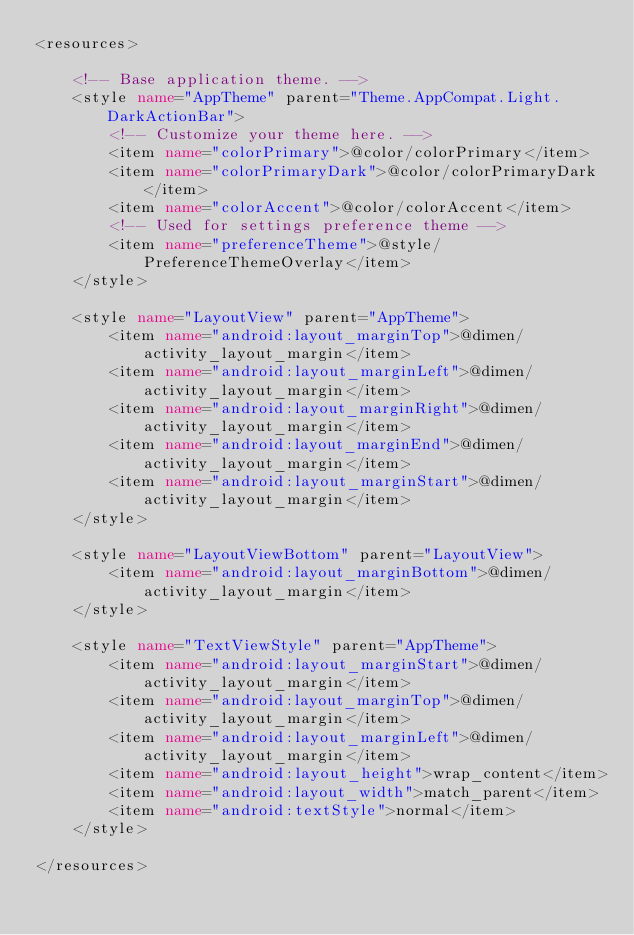Convert code to text. <code><loc_0><loc_0><loc_500><loc_500><_XML_><resources>

    <!-- Base application theme. -->
    <style name="AppTheme" parent="Theme.AppCompat.Light.DarkActionBar">
        <!-- Customize your theme here. -->
        <item name="colorPrimary">@color/colorPrimary</item>
        <item name="colorPrimaryDark">@color/colorPrimaryDark</item>
        <item name="colorAccent">@color/colorAccent</item>
        <!-- Used for settings preference theme -->
        <item name="preferenceTheme">@style/PreferenceThemeOverlay</item>
    </style>

    <style name="LayoutView" parent="AppTheme">
        <item name="android:layout_marginTop">@dimen/activity_layout_margin</item>
        <item name="android:layout_marginLeft">@dimen/activity_layout_margin</item>
        <item name="android:layout_marginRight">@dimen/activity_layout_margin</item>
        <item name="android:layout_marginEnd">@dimen/activity_layout_margin</item>
        <item name="android:layout_marginStart">@dimen/activity_layout_margin</item>
    </style>

    <style name="LayoutViewBottom" parent="LayoutView">
        <item name="android:layout_marginBottom">@dimen/activity_layout_margin</item>
    </style>

    <style name="TextViewStyle" parent="AppTheme">
        <item name="android:layout_marginStart">@dimen/activity_layout_margin</item>
        <item name="android:layout_marginTop">@dimen/activity_layout_margin</item>
        <item name="android:layout_marginLeft">@dimen/activity_layout_margin</item>
        <item name="android:layout_height">wrap_content</item>
        <item name="android:layout_width">match_parent</item>
        <item name="android:textStyle">normal</item>
    </style>

</resources>
</code> 